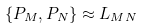Convert formula to latex. <formula><loc_0><loc_0><loc_500><loc_500>\{ P _ { M } , P _ { N } \} \approx L _ { M N }</formula> 